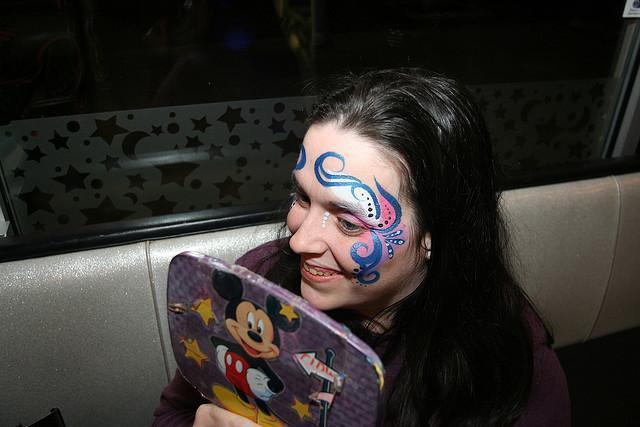Is "The person is in the middle of the couch." an appropriate description for the image?
Answer yes or no. No. 